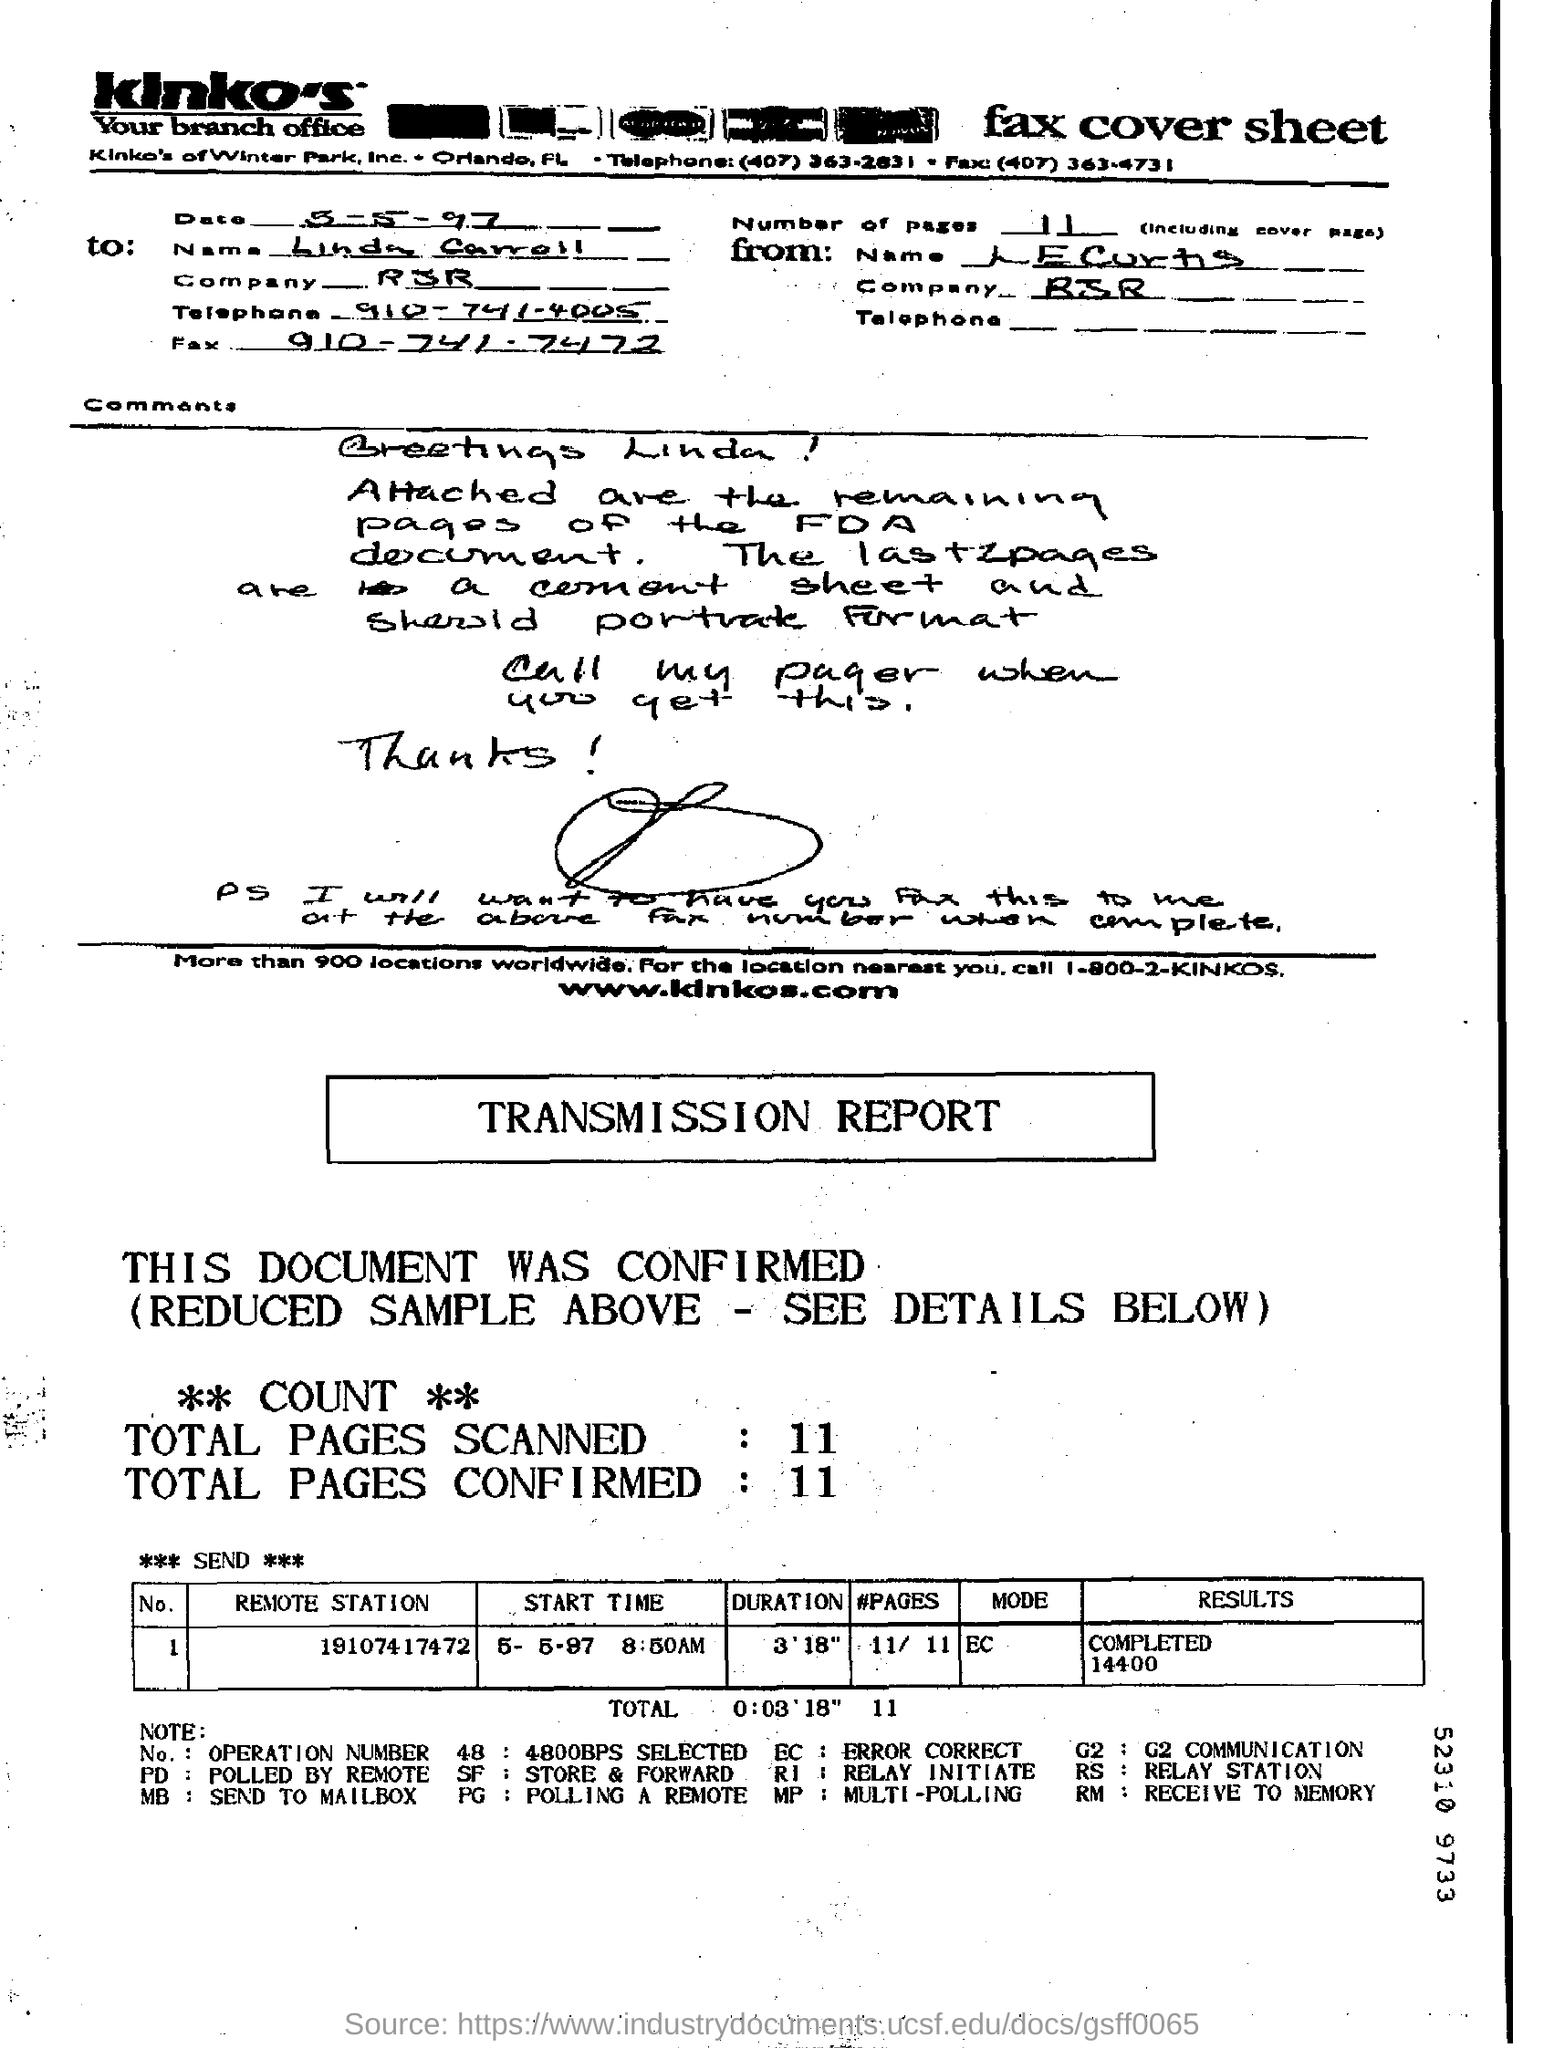What is the Date?
Your answer should be very brief. 5-5-97. What is the Company?
Your answer should be very brief. RJR. To Whom is this Fax addressed to?
Ensure brevity in your answer.  Linda Carroll. What is the "Duration" for "Remote station" "19107417472"?
Your answer should be very brief. 3'18". What is the "Results" for "Remote station" "19107417472"?
Provide a short and direct response. COMPLETED 14400. What are the Total Pages Scanned?
Make the answer very short. 11. What are the Total Pages Confirmed?
Keep it short and to the point. 11. 